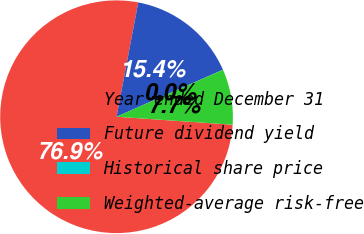<chart> <loc_0><loc_0><loc_500><loc_500><pie_chart><fcel>Year ended December 31<fcel>Future dividend yield<fcel>Historical share price<fcel>Weighted-average risk-free<nl><fcel>76.89%<fcel>15.39%<fcel>0.01%<fcel>7.7%<nl></chart> 